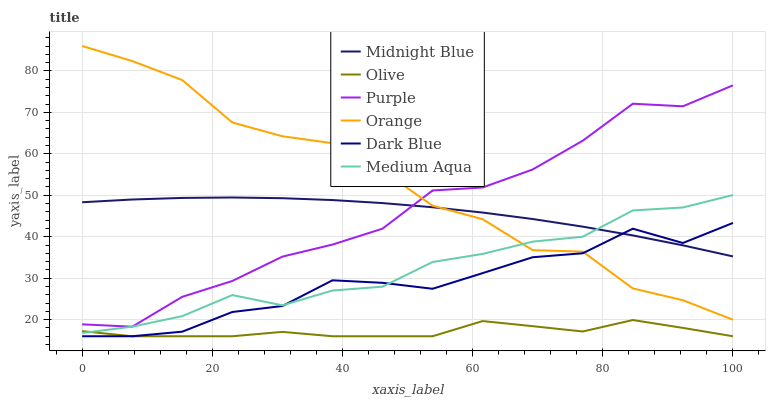Does Olive have the minimum area under the curve?
Answer yes or no. Yes. Does Orange have the maximum area under the curve?
Answer yes or no. Yes. Does Dark Blue have the minimum area under the curve?
Answer yes or no. No. Does Dark Blue have the maximum area under the curve?
Answer yes or no. No. Is Midnight Blue the smoothest?
Answer yes or no. Yes. Is Orange the roughest?
Answer yes or no. Yes. Is Dark Blue the smoothest?
Answer yes or no. No. Is Dark Blue the roughest?
Answer yes or no. No. Does Dark Blue have the lowest value?
Answer yes or no. Yes. Does Purple have the lowest value?
Answer yes or no. No. Does Orange have the highest value?
Answer yes or no. Yes. Does Dark Blue have the highest value?
Answer yes or no. No. Is Dark Blue less than Purple?
Answer yes or no. Yes. Is Midnight Blue greater than Olive?
Answer yes or no. Yes. Does Orange intersect Dark Blue?
Answer yes or no. Yes. Is Orange less than Dark Blue?
Answer yes or no. No. Is Orange greater than Dark Blue?
Answer yes or no. No. Does Dark Blue intersect Purple?
Answer yes or no. No. 